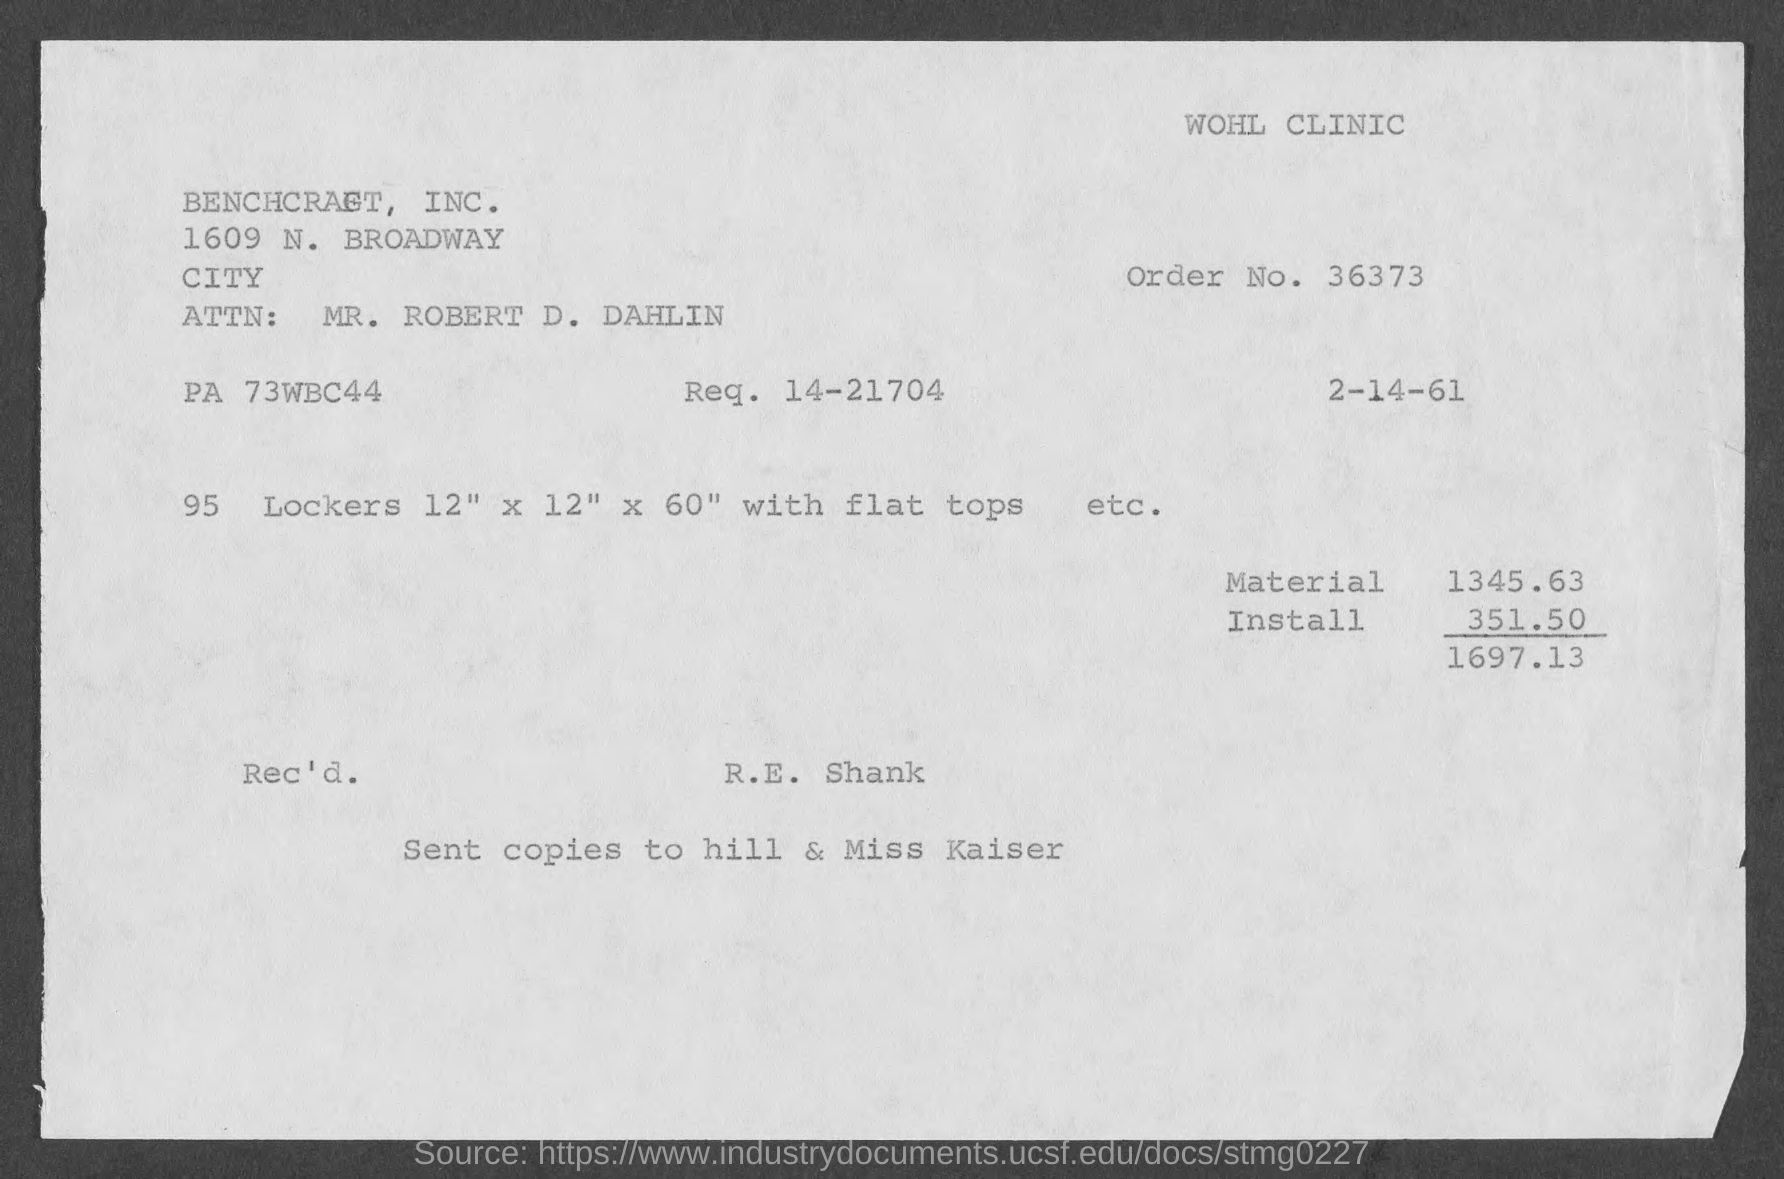What is the order no.?
Your answer should be compact. 36373. What is req. no.?
Your answer should be very brief. 14-21704. To whom are copies sent ?
Your answer should be compact. Hill & miss kaiser. What is the total amount of the order ?
Give a very brief answer. $1697.13. 